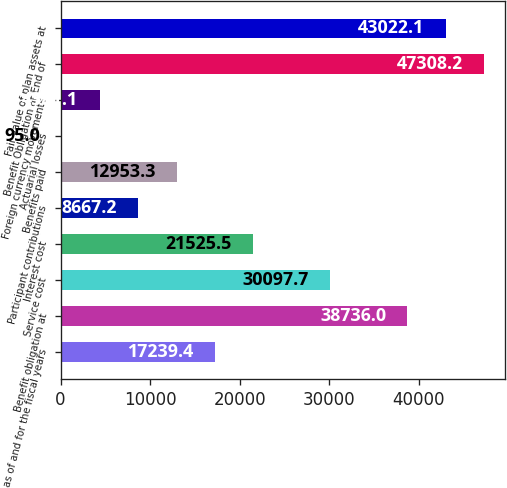<chart> <loc_0><loc_0><loc_500><loc_500><bar_chart><fcel>as of and for the fiscal years<fcel>Benefit obligation at<fcel>Service cost<fcel>Interest cost<fcel>Participant contributions<fcel>Benefits paid<fcel>Actuarial losses<fcel>Foreign currency movements<fcel>Benefit Obligation at End of<fcel>Fair value of plan assets at<nl><fcel>17239.4<fcel>38736<fcel>30097.7<fcel>21525.5<fcel>8667.2<fcel>12953.3<fcel>95<fcel>4381.1<fcel>47308.2<fcel>43022.1<nl></chart> 